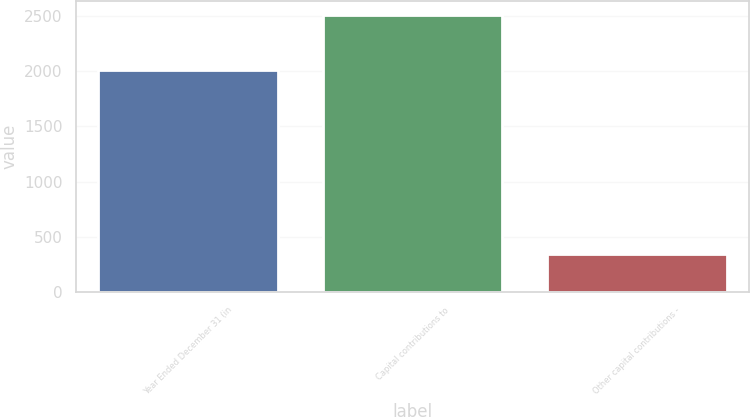Convert chart. <chart><loc_0><loc_0><loc_500><loc_500><bar_chart><fcel>Year Ended December 31 (in<fcel>Capital contributions to<fcel>Other capital contributions -<nl><fcel>2010<fcel>2510<fcel>346<nl></chart> 